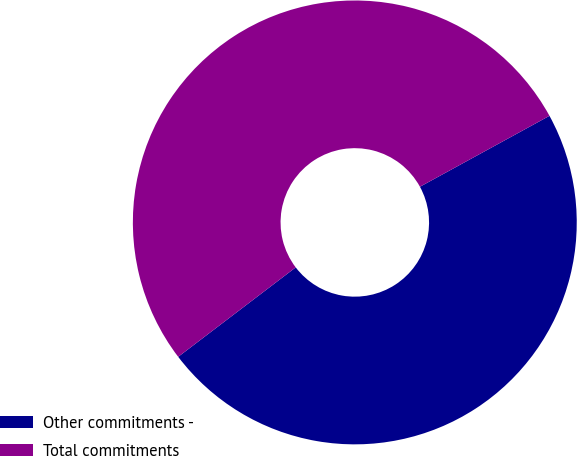<chart> <loc_0><loc_0><loc_500><loc_500><pie_chart><fcel>Other commitments -<fcel>Total commitments<nl><fcel>47.62%<fcel>52.38%<nl></chart> 